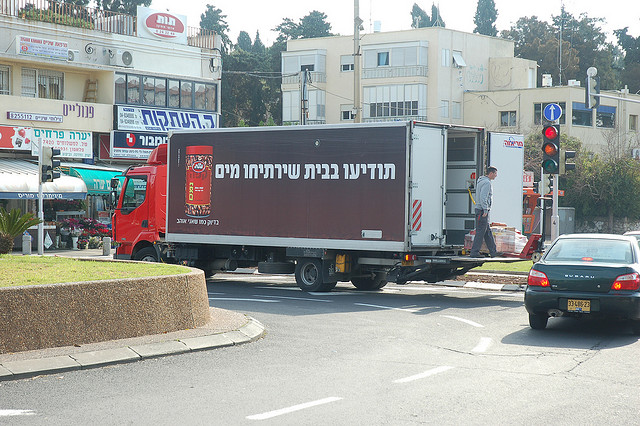<image>What soda is advertising? I am not sure which soda is being advertised. It could be 'pepsi', 'coke', or 'dr pepper'. What soda is advertising? I am not sure which soda is being advertised. It can be seen that there is a Coke and Dr Pepper can, but I cannot determine the exact one. 